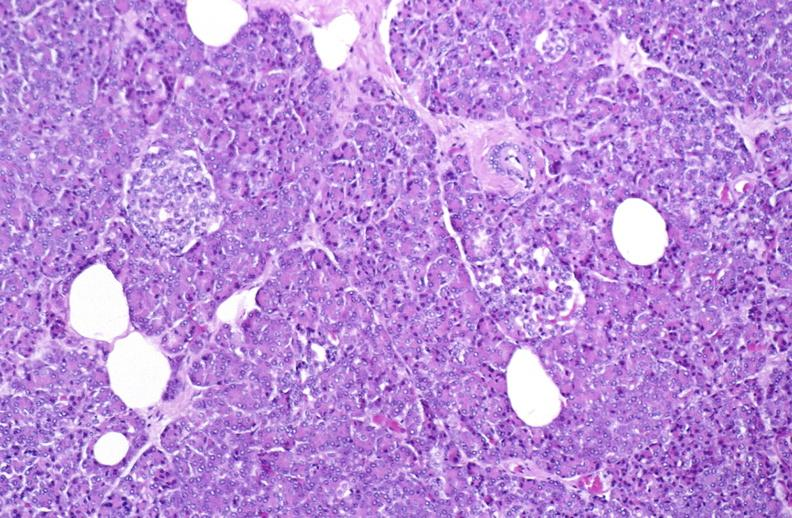does optic nerve show normal pancreas?
Answer the question using a single word or phrase. No 